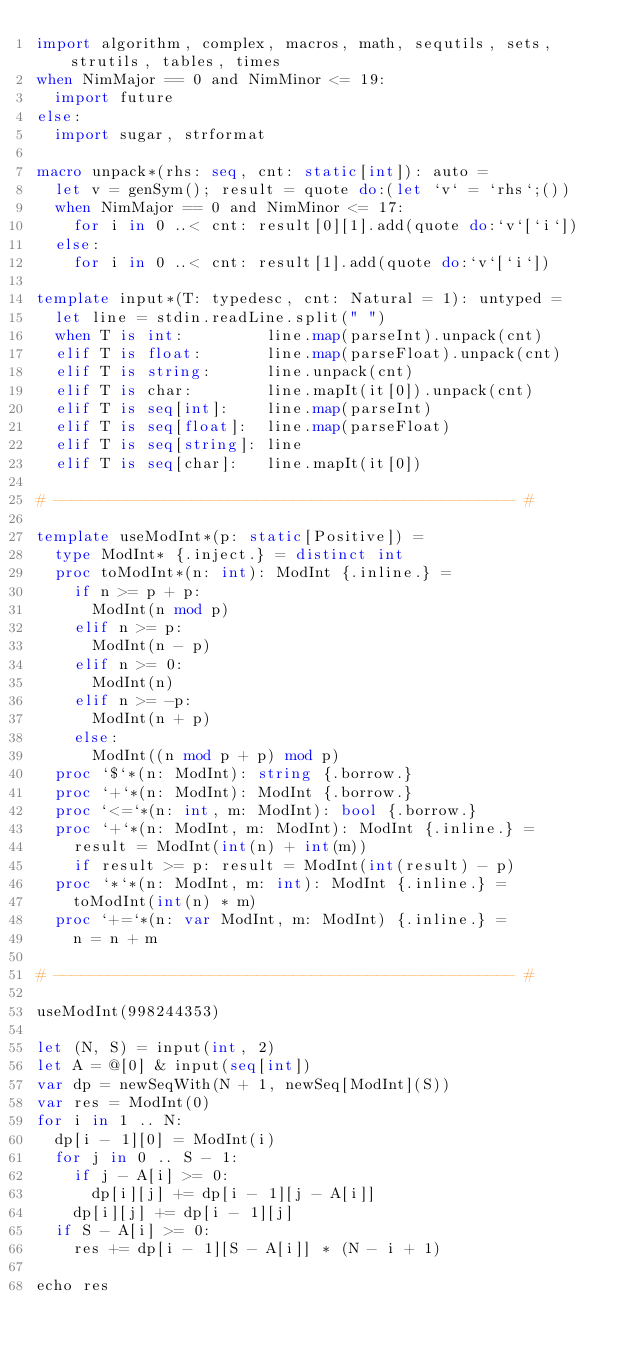Convert code to text. <code><loc_0><loc_0><loc_500><loc_500><_Nim_>import algorithm, complex, macros, math, sequtils, sets, strutils, tables, times
when NimMajor == 0 and NimMinor <= 19:
  import future
else:
  import sugar, strformat

macro unpack*(rhs: seq, cnt: static[int]): auto =
  let v = genSym(); result = quote do:(let `v` = `rhs`;())
  when NimMajor == 0 and NimMinor <= 17:
    for i in 0 ..< cnt: result[0][1].add(quote do:`v`[`i`])
  else:
    for i in 0 ..< cnt: result[1].add(quote do:`v`[`i`])

template input*(T: typedesc, cnt: Natural = 1): untyped =
  let line = stdin.readLine.split(" ")
  when T is int:         line.map(parseInt).unpack(cnt)
  elif T is float:       line.map(parseFloat).unpack(cnt)
  elif T is string:      line.unpack(cnt)
  elif T is char:        line.mapIt(it[0]).unpack(cnt)
  elif T is seq[int]:    line.map(parseInt)
  elif T is seq[float]:  line.map(parseFloat)
  elif T is seq[string]: line
  elif T is seq[char]:   line.mapIt(it[0])

# -------------------------------------------------- #

template useModInt*(p: static[Positive]) =
  type ModInt* {.inject.} = distinct int
  proc toModInt*(n: int): ModInt {.inline.} =
    if n >= p + p:
      ModInt(n mod p)
    elif n >= p:
      ModInt(n - p)
    elif n >= 0:
      ModInt(n)
    elif n >= -p:
      ModInt(n + p)
    else:
      ModInt((n mod p + p) mod p)
  proc `$`*(n: ModInt): string {.borrow.}
  proc `+`*(n: ModInt): ModInt {.borrow.}
  proc `<=`*(n: int, m: ModInt): bool {.borrow.}
  proc `+`*(n: ModInt, m: ModInt): ModInt {.inline.} =
    result = ModInt(int(n) + int(m))
    if result >= p: result = ModInt(int(result) - p)
  proc `*`*(n: ModInt, m: int): ModInt {.inline.} =
    toModInt(int(n) * m)
  proc `+=`*(n: var ModInt, m: ModInt) {.inline.} =
    n = n + m

# -------------------------------------------------- #

useModInt(998244353)

let (N, S) = input(int, 2)
let A = @[0] & input(seq[int])
var dp = newSeqWith(N + 1, newSeq[ModInt](S))
var res = ModInt(0)
for i in 1 .. N:
  dp[i - 1][0] = ModInt(i)
  for j in 0 .. S - 1:
    if j - A[i] >= 0:
      dp[i][j] += dp[i - 1][j - A[i]]
    dp[i][j] += dp[i - 1][j]
  if S - A[i] >= 0:
    res += dp[i - 1][S - A[i]] * (N - i + 1)

echo res</code> 